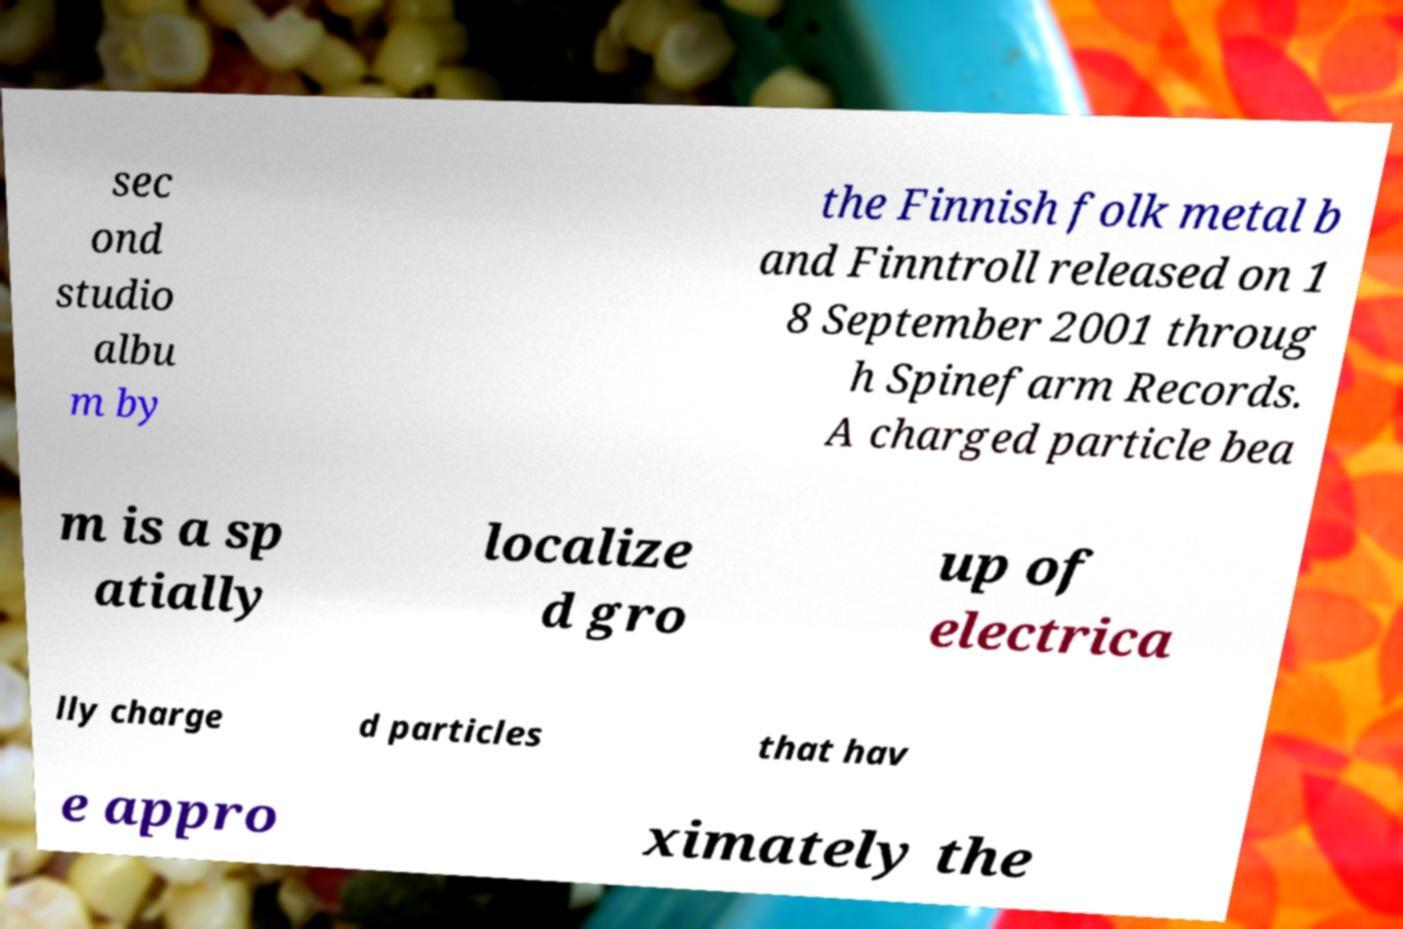What messages or text are displayed in this image? I need them in a readable, typed format. sec ond studio albu m by the Finnish folk metal b and Finntroll released on 1 8 September 2001 throug h Spinefarm Records. A charged particle bea m is a sp atially localize d gro up of electrica lly charge d particles that hav e appro ximately the 